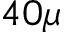<formula> <loc_0><loc_0><loc_500><loc_500>4 0 \mu</formula> 